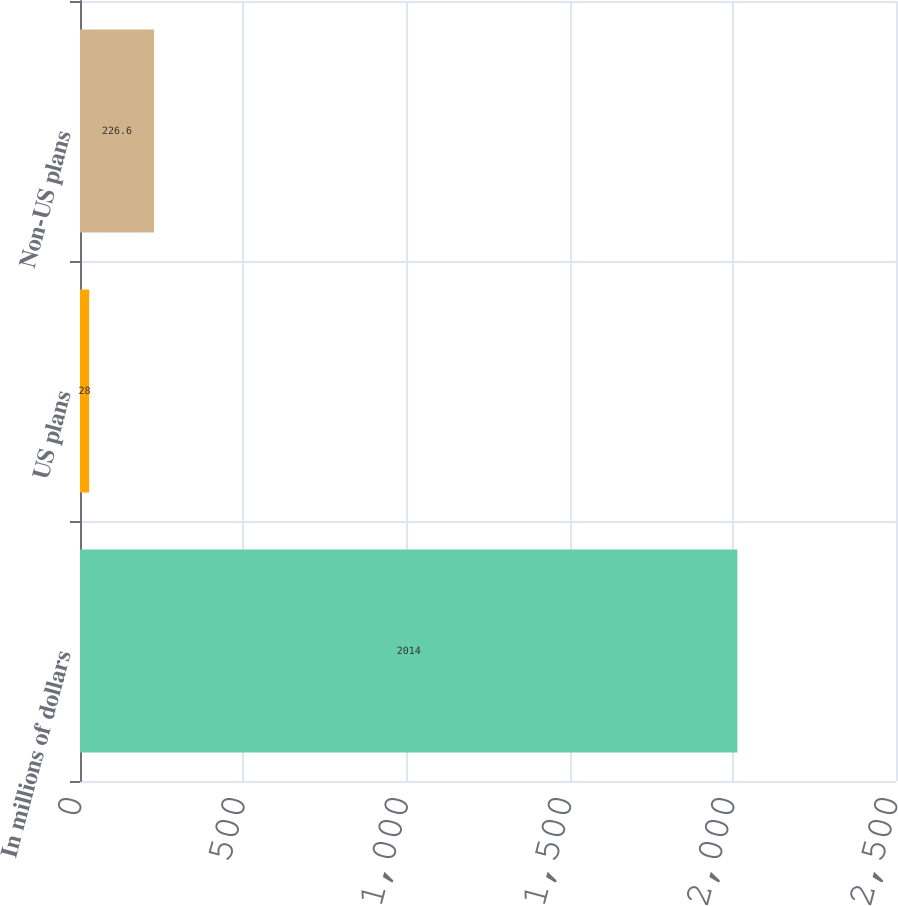<chart> <loc_0><loc_0><loc_500><loc_500><bar_chart><fcel>In millions of dollars<fcel>US plans<fcel>Non-US plans<nl><fcel>2014<fcel>28<fcel>226.6<nl></chart> 